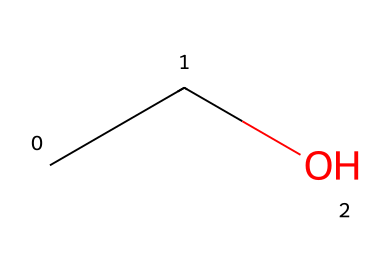What is the chemical name of the structure represented? The SMILES representation CC(O) indicates that the chemical consists of two carbon atoms (the "CC" part) and one hydroxyl group (-OH, indicated by "O"), defining it as ethanol.
Answer: ethanol How many carbon atoms are in the molecule? The SMILES code CC indicates there are two carbon atoms present in the structure.
Answer: 2 What functional group is present in this molecule? The hydroxyl group (-OH) is indicated by the "O" in the SMILES representation, making it an alcohol.
Answer: hydroxyl Is ethanol a polar or non-polar molecule? The presence of the hydroxyl group contributes to a polar character, while the carbon chain (C-C) contributes to non-polar character; however, the hydroxyl group dominates, making ethanol polar overall.
Answer: polar What is the total number of hydrogen atoms in this molecule? Analyzing the structure, each carbon atom can bond to enough hydrogens to fulfill carbon's tetravalency, resulting in a total of six hydrogen atoms when counted.
Answer: 6 What type of compound is ethanol classified as, based on its ability to dissolve in water? Since ethanol mixes well with water due to its polar nature from the hydroxyl group, it is classified as a soluble compound.
Answer: soluble Does ethanol conduct electricity when dissolved in water? Ethanol is a non-electrolyte, which means it does not dissociate into ions in solution and therefore does not conduct electricity well.
Answer: no 